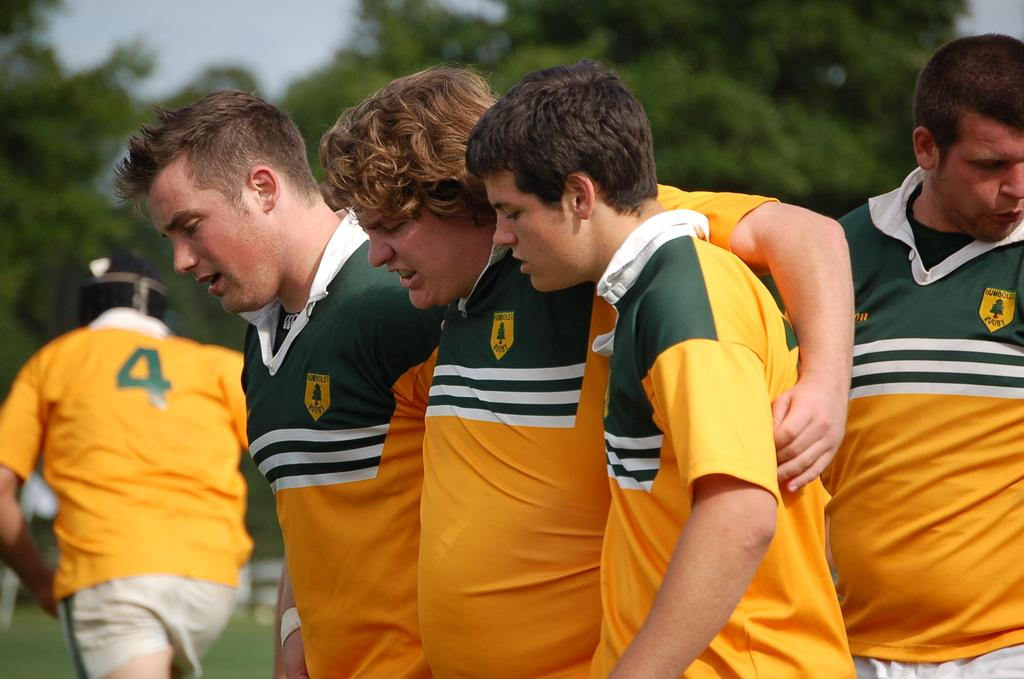<image>
Describe the image concisely. young men in green and yellow RUGBY shirts one with a number 4 on it 